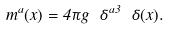Convert formula to latex. <formula><loc_0><loc_0><loc_500><loc_500>m ^ { a } ( x ) = 4 \pi g \ \delta ^ { a 3 } \ \delta ( x ) .</formula> 